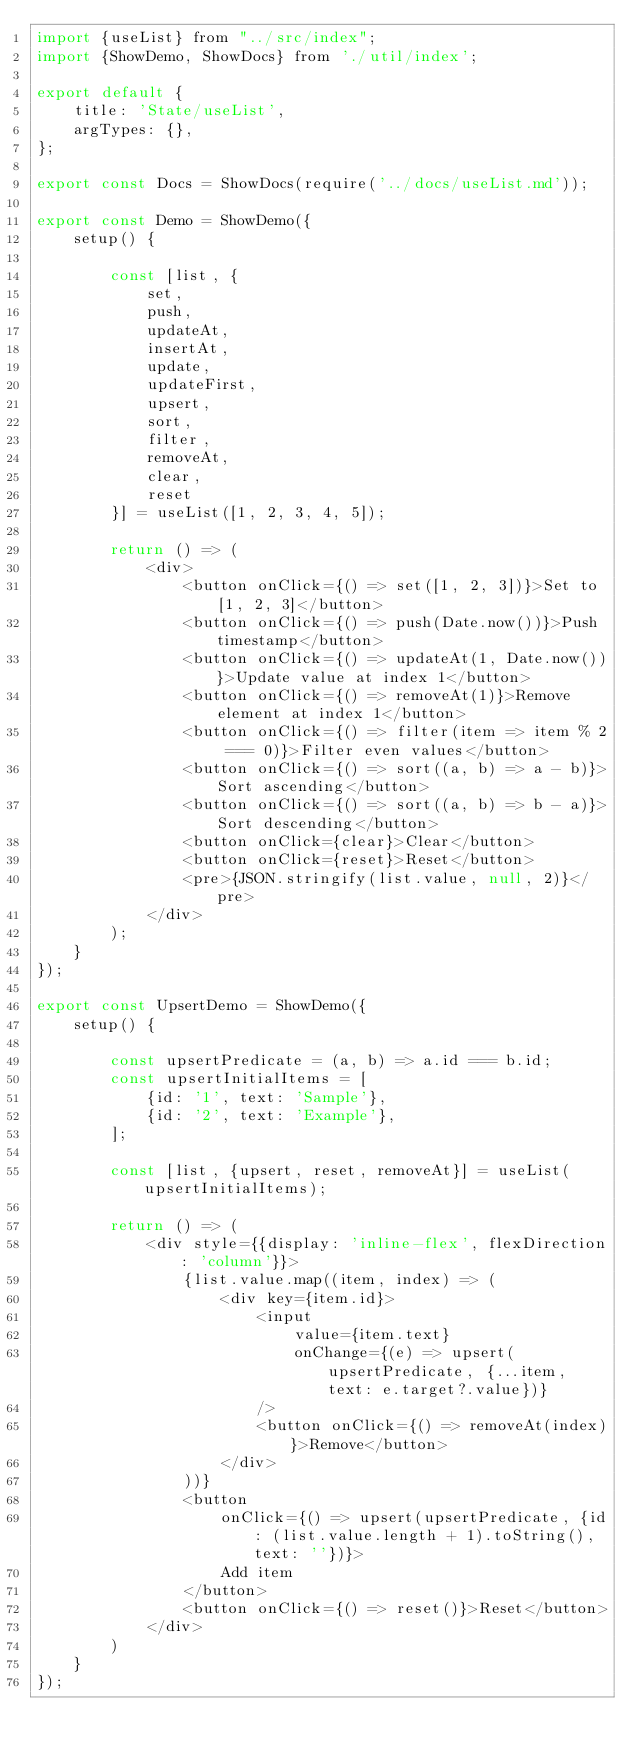<code> <loc_0><loc_0><loc_500><loc_500><_JavaScript_>import {useList} from "../src/index";
import {ShowDemo, ShowDocs} from './util/index';

export default {
    title: 'State/useList',
    argTypes: {},
};

export const Docs = ShowDocs(require('../docs/useList.md'));

export const Demo = ShowDemo({
    setup() {

        const [list, {
            set,
            push,
            updateAt,
            insertAt,
            update,
            updateFirst,
            upsert,
            sort,
            filter,
            removeAt,
            clear,
            reset
        }] = useList([1, 2, 3, 4, 5]);

        return () => (
            <div>
                <button onClick={() => set([1, 2, 3])}>Set to [1, 2, 3]</button>
                <button onClick={() => push(Date.now())}>Push timestamp</button>
                <button onClick={() => updateAt(1, Date.now())}>Update value at index 1</button>
                <button onClick={() => removeAt(1)}>Remove element at index 1</button>
                <button onClick={() => filter(item => item % 2 === 0)}>Filter even values</button>
                <button onClick={() => sort((a, b) => a - b)}>Sort ascending</button>
                <button onClick={() => sort((a, b) => b - a)}>Sort descending</button>
                <button onClick={clear}>Clear</button>
                <button onClick={reset}>Reset</button>
                <pre>{JSON.stringify(list.value, null, 2)}</pre>
            </div>
        );
    }
});

export const UpsertDemo = ShowDemo({
    setup() {

        const upsertPredicate = (a, b) => a.id === b.id;
        const upsertInitialItems = [
            {id: '1', text: 'Sample'},
            {id: '2', text: 'Example'},
        ];

        const [list, {upsert, reset, removeAt}] = useList(upsertInitialItems);

        return () => (
            <div style={{display: 'inline-flex', flexDirection: 'column'}}>
                {list.value.map((item, index) => (
                    <div key={item.id}>
                        <input
                            value={item.text}
                            onChange={(e) => upsert(upsertPredicate, {...item, text: e.target?.value})}
                        />
                        <button onClick={() => removeAt(index)}>Remove</button>
                    </div>
                ))}
                <button
                    onClick={() => upsert(upsertPredicate, {id: (list.value.length + 1).toString(), text: ''})}>
                    Add item
                </button>
                <button onClick={() => reset()}>Reset</button>
            </div>
        )
    }
});

</code> 